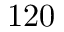<formula> <loc_0><loc_0><loc_500><loc_500>1 2 0</formula> 